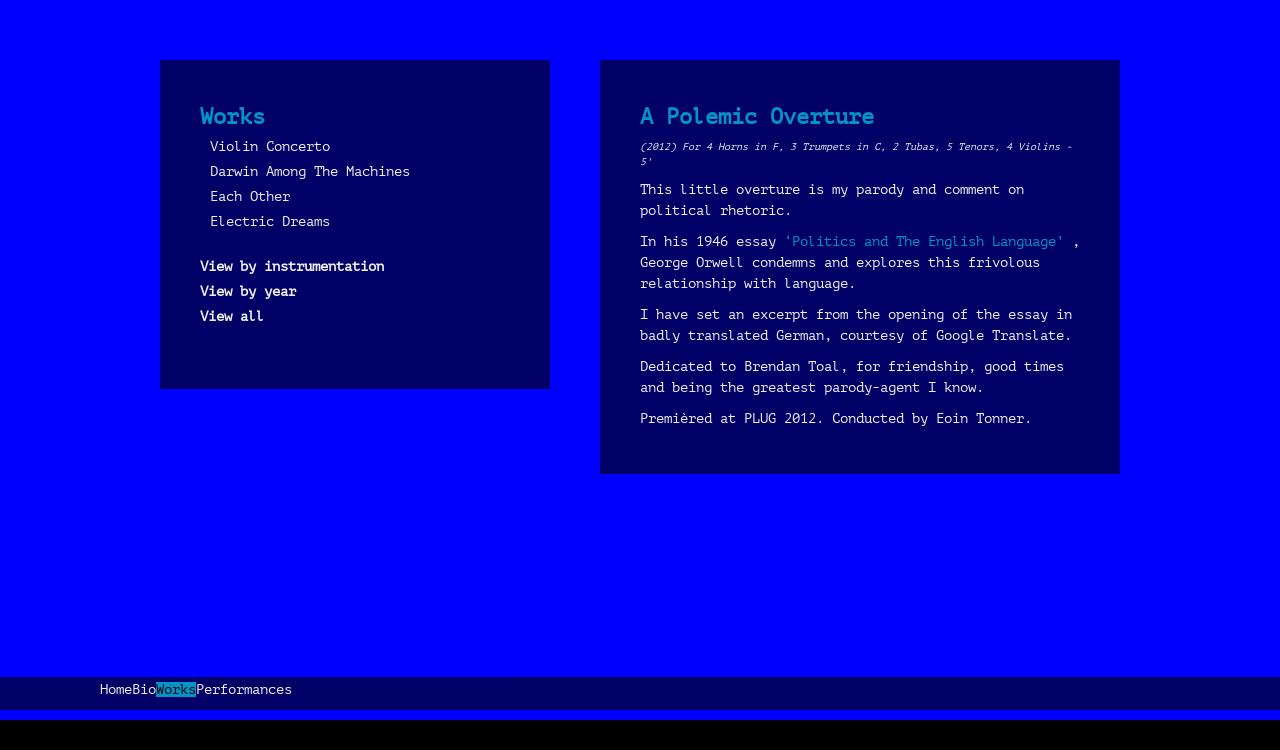How can I view the compositions by year or by instrumentation as suggested in the image? To view compositions by year or instrumentation on the website displayed in the image, you would typically interact with the options listed under the 'Works' section. Selecting 'View by instrumentation' would presumably organize the works according to the musical instruments featured, whereas selecting 'View by year' would display the works chronologically. Such features help users to explore the composer's body of work based on their preferences for certain periods or instrumental setups. 